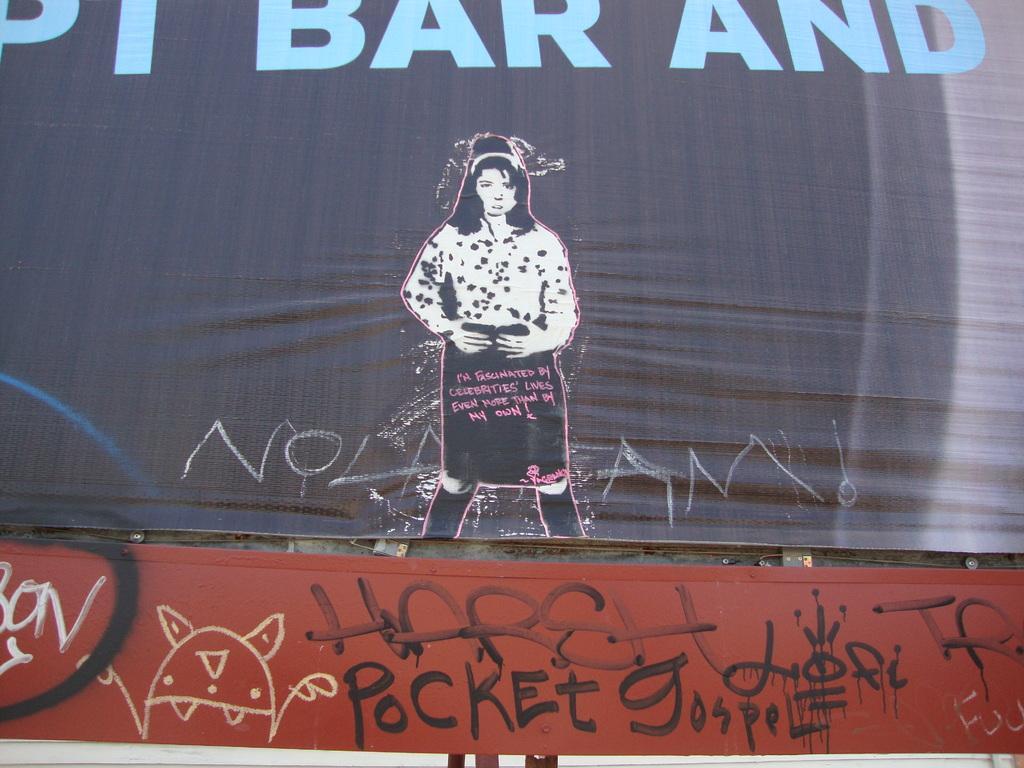Describe this image in one or two sentences. The picture consists of of banners. In the center of the picture there is a woman. At the bottom there is text. At the top there is text. 